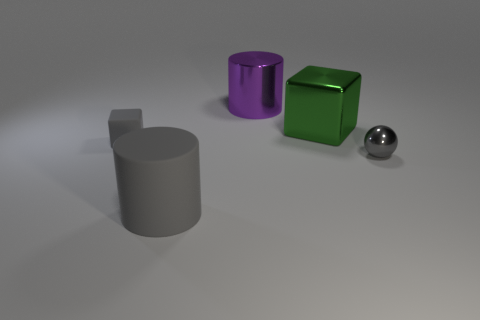Add 4 shiny spheres. How many objects exist? 9 Subtract all cylinders. How many objects are left? 3 Subtract all tiny cylinders. Subtract all matte blocks. How many objects are left? 4 Add 2 spheres. How many spheres are left? 3 Add 2 gray cylinders. How many gray cylinders exist? 3 Subtract 1 gray blocks. How many objects are left? 4 